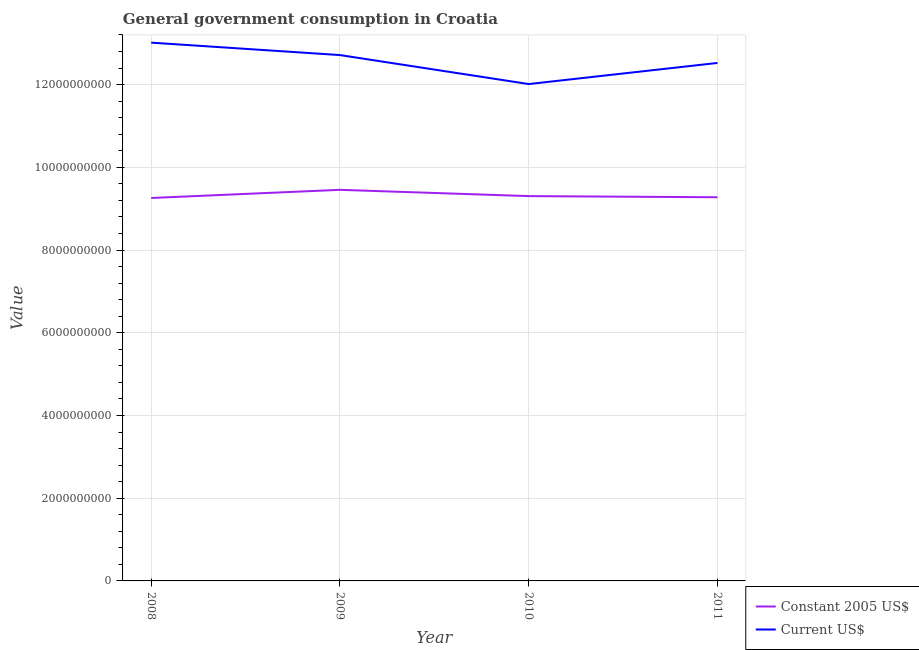Does the line corresponding to value consumed in current us$ intersect with the line corresponding to value consumed in constant 2005 us$?
Give a very brief answer. No. What is the value consumed in current us$ in 2010?
Ensure brevity in your answer.  1.20e+1. Across all years, what is the maximum value consumed in current us$?
Your answer should be very brief. 1.30e+1. Across all years, what is the minimum value consumed in constant 2005 us$?
Keep it short and to the point. 9.26e+09. What is the total value consumed in current us$ in the graph?
Offer a very short reply. 5.03e+1. What is the difference between the value consumed in constant 2005 us$ in 2010 and that in 2011?
Provide a short and direct response. 2.73e+07. What is the difference between the value consumed in constant 2005 us$ in 2010 and the value consumed in current us$ in 2008?
Make the answer very short. -3.71e+09. What is the average value consumed in constant 2005 us$ per year?
Give a very brief answer. 9.32e+09. In the year 2010, what is the difference between the value consumed in constant 2005 us$ and value consumed in current us$?
Your response must be concise. -2.71e+09. What is the ratio of the value consumed in current us$ in 2008 to that in 2009?
Offer a terse response. 1.02. Is the value consumed in current us$ in 2008 less than that in 2011?
Keep it short and to the point. No. What is the difference between the highest and the second highest value consumed in current us$?
Make the answer very short. 3.01e+08. What is the difference between the highest and the lowest value consumed in current us$?
Your response must be concise. 1.00e+09. Is the sum of the value consumed in constant 2005 us$ in 2009 and 2011 greater than the maximum value consumed in current us$ across all years?
Ensure brevity in your answer.  Yes. Does the value consumed in current us$ monotonically increase over the years?
Your answer should be very brief. No. How many years are there in the graph?
Make the answer very short. 4. Are the values on the major ticks of Y-axis written in scientific E-notation?
Offer a terse response. No. Does the graph contain grids?
Your response must be concise. Yes. What is the title of the graph?
Your response must be concise. General government consumption in Croatia. What is the label or title of the X-axis?
Provide a short and direct response. Year. What is the label or title of the Y-axis?
Give a very brief answer. Value. What is the Value of Constant 2005 US$ in 2008?
Your response must be concise. 9.26e+09. What is the Value of Current US$ in 2008?
Your response must be concise. 1.30e+1. What is the Value in Constant 2005 US$ in 2009?
Provide a succinct answer. 9.46e+09. What is the Value in Current US$ in 2009?
Your answer should be compact. 1.27e+1. What is the Value in Constant 2005 US$ in 2010?
Your response must be concise. 9.30e+09. What is the Value of Current US$ in 2010?
Your answer should be compact. 1.20e+1. What is the Value of Constant 2005 US$ in 2011?
Provide a short and direct response. 9.28e+09. What is the Value of Current US$ in 2011?
Your answer should be compact. 1.25e+1. Across all years, what is the maximum Value in Constant 2005 US$?
Your answer should be compact. 9.46e+09. Across all years, what is the maximum Value in Current US$?
Provide a succinct answer. 1.30e+1. Across all years, what is the minimum Value of Constant 2005 US$?
Your response must be concise. 9.26e+09. Across all years, what is the minimum Value of Current US$?
Offer a terse response. 1.20e+1. What is the total Value of Constant 2005 US$ in the graph?
Make the answer very short. 3.73e+1. What is the total Value in Current US$ in the graph?
Provide a short and direct response. 5.03e+1. What is the difference between the Value of Constant 2005 US$ in 2008 and that in 2009?
Provide a short and direct response. -1.97e+08. What is the difference between the Value of Current US$ in 2008 and that in 2009?
Offer a very short reply. 3.01e+08. What is the difference between the Value of Constant 2005 US$ in 2008 and that in 2010?
Your response must be concise. -4.51e+07. What is the difference between the Value of Current US$ in 2008 and that in 2010?
Your answer should be very brief. 1.00e+09. What is the difference between the Value of Constant 2005 US$ in 2008 and that in 2011?
Keep it short and to the point. -1.78e+07. What is the difference between the Value of Current US$ in 2008 and that in 2011?
Give a very brief answer. 4.91e+08. What is the difference between the Value in Constant 2005 US$ in 2009 and that in 2010?
Offer a very short reply. 1.52e+08. What is the difference between the Value in Current US$ in 2009 and that in 2010?
Keep it short and to the point. 7.01e+08. What is the difference between the Value of Constant 2005 US$ in 2009 and that in 2011?
Offer a terse response. 1.79e+08. What is the difference between the Value of Current US$ in 2009 and that in 2011?
Give a very brief answer. 1.90e+08. What is the difference between the Value in Constant 2005 US$ in 2010 and that in 2011?
Keep it short and to the point. 2.73e+07. What is the difference between the Value in Current US$ in 2010 and that in 2011?
Your answer should be compact. -5.10e+08. What is the difference between the Value in Constant 2005 US$ in 2008 and the Value in Current US$ in 2009?
Offer a terse response. -3.46e+09. What is the difference between the Value in Constant 2005 US$ in 2008 and the Value in Current US$ in 2010?
Keep it short and to the point. -2.75e+09. What is the difference between the Value of Constant 2005 US$ in 2008 and the Value of Current US$ in 2011?
Provide a succinct answer. -3.26e+09. What is the difference between the Value of Constant 2005 US$ in 2009 and the Value of Current US$ in 2010?
Offer a terse response. -2.56e+09. What is the difference between the Value of Constant 2005 US$ in 2009 and the Value of Current US$ in 2011?
Your response must be concise. -3.07e+09. What is the difference between the Value of Constant 2005 US$ in 2010 and the Value of Current US$ in 2011?
Make the answer very short. -3.22e+09. What is the average Value of Constant 2005 US$ per year?
Provide a succinct answer. 9.32e+09. What is the average Value of Current US$ per year?
Provide a short and direct response. 1.26e+1. In the year 2008, what is the difference between the Value of Constant 2005 US$ and Value of Current US$?
Your answer should be compact. -3.76e+09. In the year 2009, what is the difference between the Value in Constant 2005 US$ and Value in Current US$?
Keep it short and to the point. -3.26e+09. In the year 2010, what is the difference between the Value of Constant 2005 US$ and Value of Current US$?
Give a very brief answer. -2.71e+09. In the year 2011, what is the difference between the Value in Constant 2005 US$ and Value in Current US$?
Provide a short and direct response. -3.25e+09. What is the ratio of the Value of Constant 2005 US$ in 2008 to that in 2009?
Provide a succinct answer. 0.98. What is the ratio of the Value of Current US$ in 2008 to that in 2009?
Keep it short and to the point. 1.02. What is the ratio of the Value of Constant 2005 US$ in 2008 to that in 2010?
Make the answer very short. 1. What is the ratio of the Value in Current US$ in 2008 to that in 2011?
Provide a short and direct response. 1.04. What is the ratio of the Value of Constant 2005 US$ in 2009 to that in 2010?
Your answer should be compact. 1.02. What is the ratio of the Value in Current US$ in 2009 to that in 2010?
Give a very brief answer. 1.06. What is the ratio of the Value in Constant 2005 US$ in 2009 to that in 2011?
Offer a terse response. 1.02. What is the ratio of the Value of Current US$ in 2009 to that in 2011?
Your answer should be compact. 1.02. What is the ratio of the Value in Current US$ in 2010 to that in 2011?
Make the answer very short. 0.96. What is the difference between the highest and the second highest Value of Constant 2005 US$?
Your answer should be compact. 1.52e+08. What is the difference between the highest and the second highest Value in Current US$?
Offer a very short reply. 3.01e+08. What is the difference between the highest and the lowest Value in Constant 2005 US$?
Provide a succinct answer. 1.97e+08. What is the difference between the highest and the lowest Value in Current US$?
Offer a terse response. 1.00e+09. 